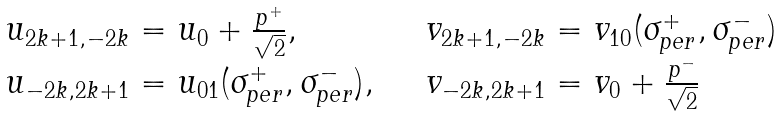<formula> <loc_0><loc_0><loc_500><loc_500>\begin{array} { l l } u _ { 2 k + 1 , - 2 k } = u _ { 0 } + { \frac { p ^ { + } } { \sqrt { 2 } } } , & \quad v _ { 2 k + 1 , - 2 k } = v _ { 1 0 } ( \sigma _ { p e r } ^ { + } , \sigma _ { p e r } ^ { - } ) \\ u _ { - 2 k , 2 k + 1 } = u _ { 0 1 } ( \sigma _ { p e r } ^ { + } , \sigma _ { p e r } ^ { - } ) , & \quad v _ { - 2 k , 2 k + 1 } = v _ { 0 } + \frac { p ^ { - } } { \sqrt { 2 } } \end{array}</formula> 